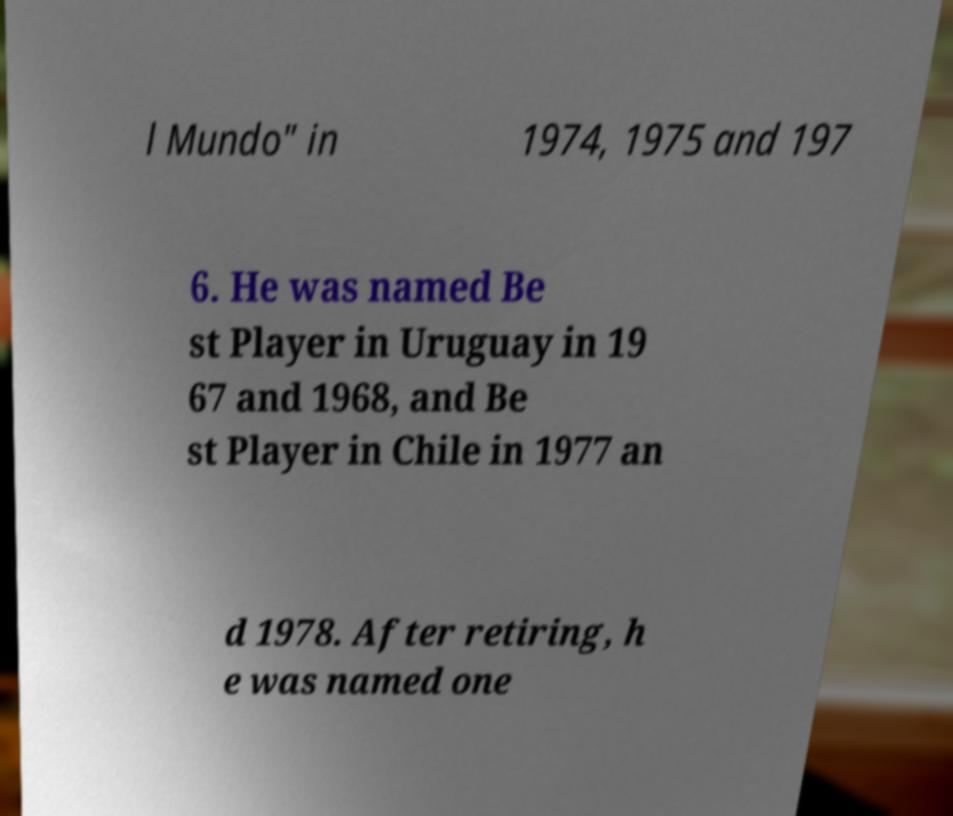What messages or text are displayed in this image? I need them in a readable, typed format. l Mundo" in 1974, 1975 and 197 6. He was named Be st Player in Uruguay in 19 67 and 1968, and Be st Player in Chile in 1977 an d 1978. After retiring, h e was named one 